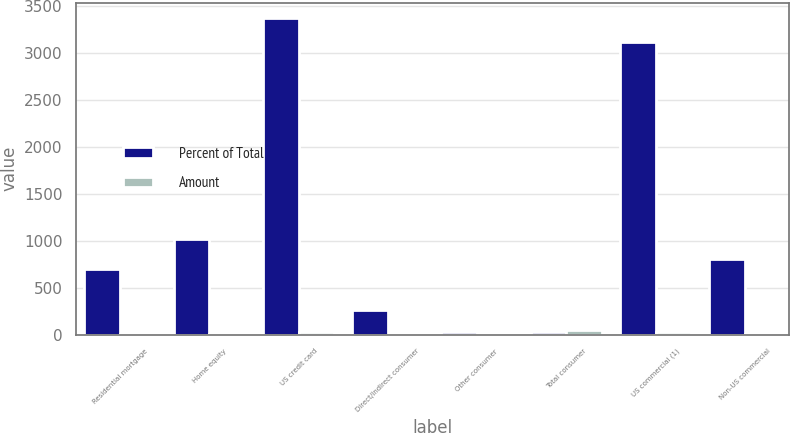Convert chart to OTSL. <chart><loc_0><loc_0><loc_500><loc_500><stacked_bar_chart><ecel><fcel>Residential mortgage<fcel>Home equity<fcel>US credit card<fcel>Direct/Indirect consumer<fcel>Other consumer<fcel>Total consumer<fcel>US commercial (1)<fcel>Non-US commercial<nl><fcel>Percent of Total<fcel>701<fcel>1019<fcel>3368<fcel>262<fcel>33<fcel>33<fcel>3113<fcel>803<nl><fcel>Amount<fcel>6.74<fcel>9.8<fcel>32.41<fcel>2.52<fcel>0.32<fcel>51.79<fcel>29.95<fcel>7.73<nl></chart> 